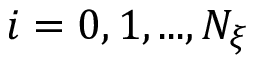<formula> <loc_0><loc_0><loc_500><loc_500>i = 0 , 1 , \dots , N _ { \xi }</formula> 